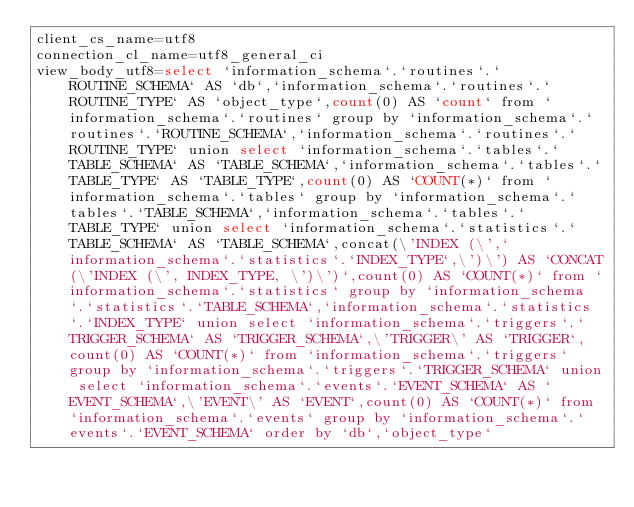Convert code to text. <code><loc_0><loc_0><loc_500><loc_500><_VisualBasic_>client_cs_name=utf8
connection_cl_name=utf8_general_ci
view_body_utf8=select `information_schema`.`routines`.`ROUTINE_SCHEMA` AS `db`,`information_schema`.`routines`.`ROUTINE_TYPE` AS `object_type`,count(0) AS `count` from `information_schema`.`routines` group by `information_schema`.`routines`.`ROUTINE_SCHEMA`,`information_schema`.`routines`.`ROUTINE_TYPE` union select `information_schema`.`tables`.`TABLE_SCHEMA` AS `TABLE_SCHEMA`,`information_schema`.`tables`.`TABLE_TYPE` AS `TABLE_TYPE`,count(0) AS `COUNT(*)` from `information_schema`.`tables` group by `information_schema`.`tables`.`TABLE_SCHEMA`,`information_schema`.`tables`.`TABLE_TYPE` union select `information_schema`.`statistics`.`TABLE_SCHEMA` AS `TABLE_SCHEMA`,concat(\'INDEX (\',`information_schema`.`statistics`.`INDEX_TYPE`,\')\') AS `CONCAT(\'INDEX (\', INDEX_TYPE, \')\')`,count(0) AS `COUNT(*)` from `information_schema`.`statistics` group by `information_schema`.`statistics`.`TABLE_SCHEMA`,`information_schema`.`statistics`.`INDEX_TYPE` union select `information_schema`.`triggers`.`TRIGGER_SCHEMA` AS `TRIGGER_SCHEMA`,\'TRIGGER\' AS `TRIGGER`,count(0) AS `COUNT(*)` from `information_schema`.`triggers` group by `information_schema`.`triggers`.`TRIGGER_SCHEMA` union select `information_schema`.`events`.`EVENT_SCHEMA` AS `EVENT_SCHEMA`,\'EVENT\' AS `EVENT`,count(0) AS `COUNT(*)` from `information_schema`.`events` group by `information_schema`.`events`.`EVENT_SCHEMA` order by `db`,`object_type`
</code> 